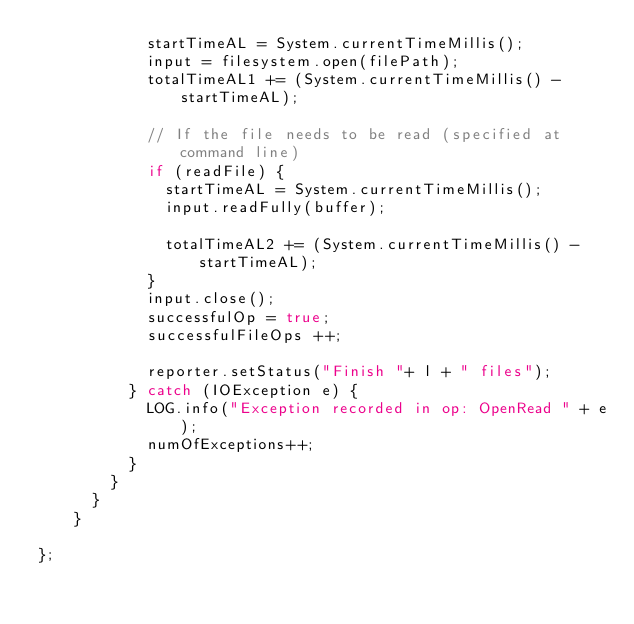Convert code to text. <code><loc_0><loc_0><loc_500><loc_500><_Java_>            startTimeAL = System.currentTimeMillis();
            input = filesystem.open(filePath);
            totalTimeAL1 += (System.currentTimeMillis() - startTimeAL);
            
            // If the file needs to be read (specified at command line)
            if (readFile) {
              startTimeAL = System.currentTimeMillis();
              input.readFully(buffer);

              totalTimeAL2 += (System.currentTimeMillis() - startTimeAL);
            }
            input.close();
            successfulOp = true;
            successfulFileOps ++;

            reporter.setStatus("Finish "+ l + " files");
          } catch (IOException e) {
            LOG.info("Exception recorded in op: OpenRead " + e);
            numOfExceptions++;
          }
        }
      }
    }

};</code> 